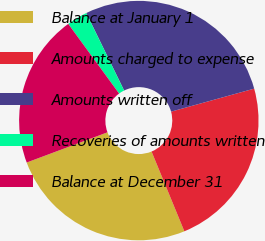Convert chart to OTSL. <chart><loc_0><loc_0><loc_500><loc_500><pie_chart><fcel>Balance at January 1<fcel>Amounts charged to expense<fcel>Amounts written off<fcel>Recoveries of amounts written<fcel>Balance at December 31<nl><fcel>25.51%<fcel>23.09%<fcel>27.93%<fcel>2.8%<fcel>20.66%<nl></chart> 